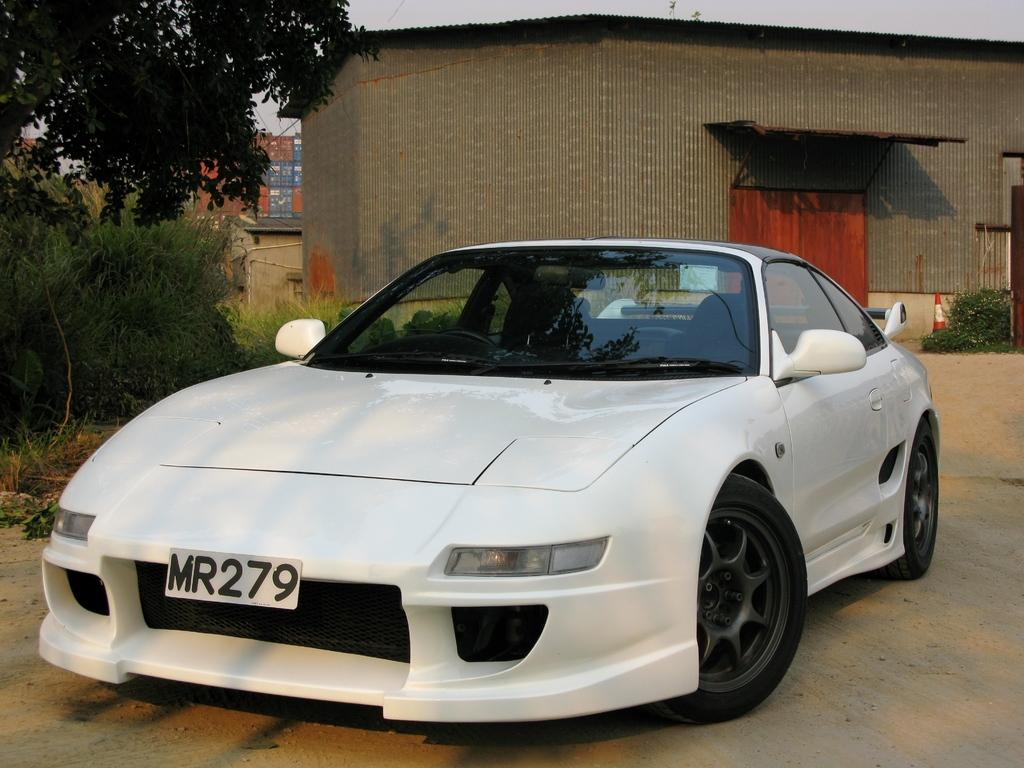What type of vehicle is in the middle of the image? There is a white car in the middle of the image. What can be seen in the background of the image? There is a house in the background of the image. What type of vegetation is on the left side of the image? There are trees on the left side of the image. What type of cable can be seen connecting the heart to the vein in the image? There is no cable, heart, or vein present in the image. 